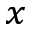<formula> <loc_0><loc_0><loc_500><loc_500>{ _ { x } }</formula> 